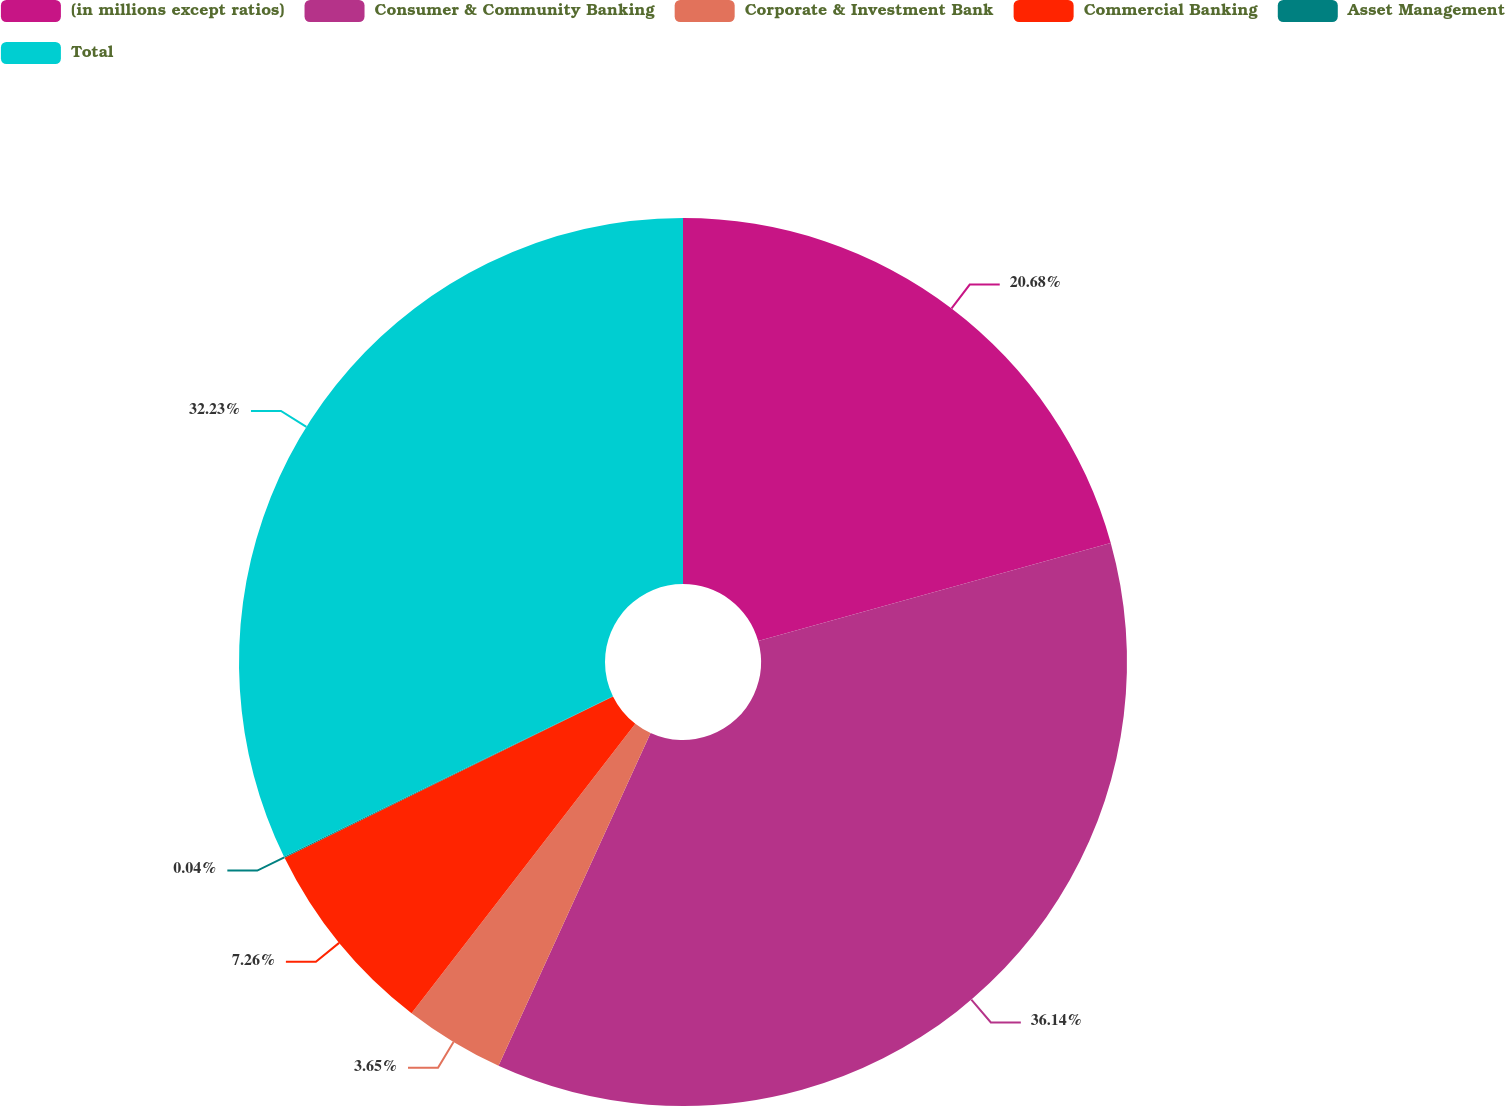Convert chart to OTSL. <chart><loc_0><loc_0><loc_500><loc_500><pie_chart><fcel>(in millions except ratios)<fcel>Consumer & Community Banking<fcel>Corporate & Investment Bank<fcel>Commercial Banking<fcel>Asset Management<fcel>Total<nl><fcel>20.68%<fcel>36.14%<fcel>3.65%<fcel>7.26%<fcel>0.04%<fcel>32.23%<nl></chart> 